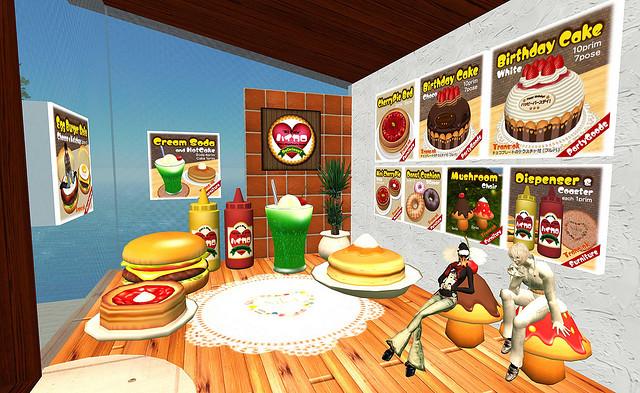What are the people sitting on?
Answer briefly. Mushrooms. What is on the table?
Short answer required. Food. Is this a real image?
Answer briefly. No. 